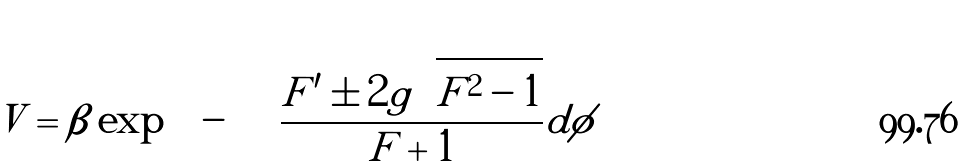Convert formula to latex. <formula><loc_0><loc_0><loc_500><loc_500>V = \beta \exp \left ( - \int \frac { F ^ { \prime } \pm 2 g \sqrt { F ^ { 2 } - 1 } } { F + 1 } d \phi \right ) \</formula> 